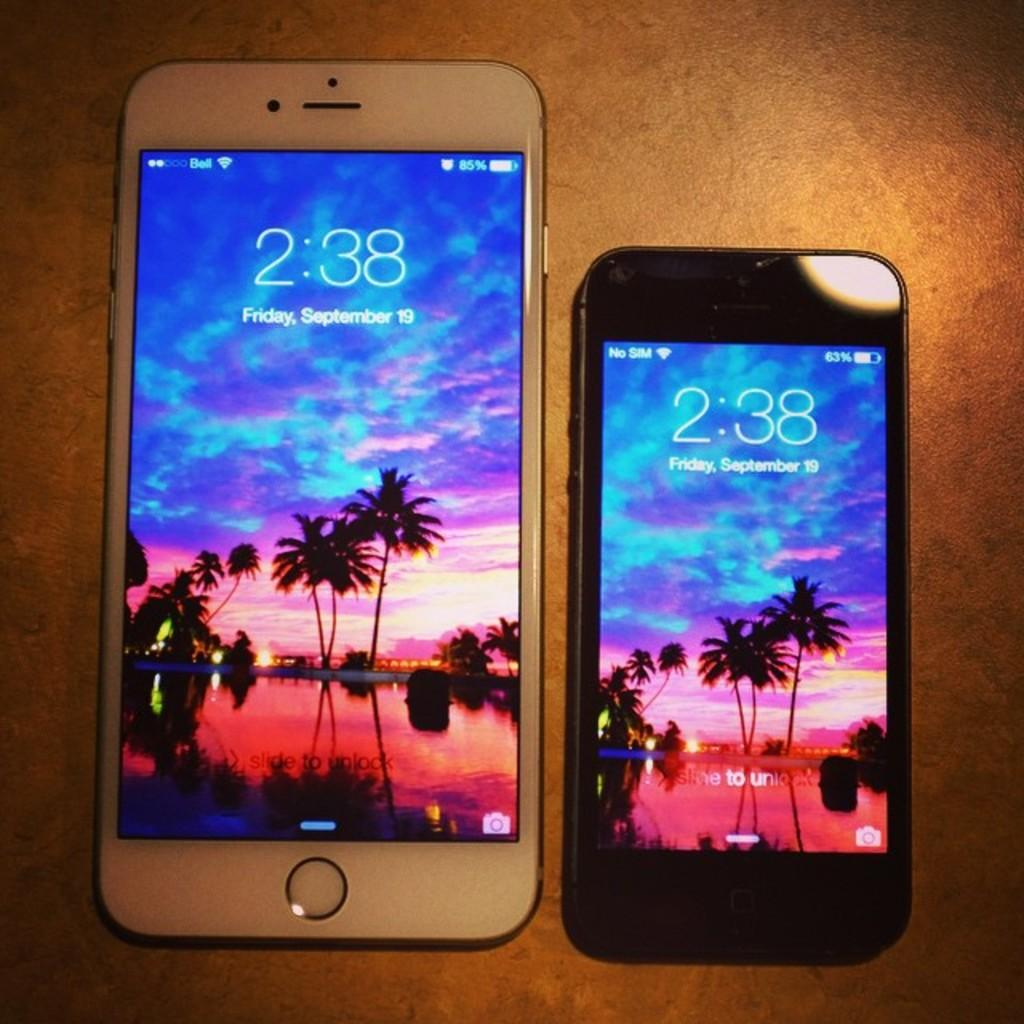<image>
Create a compact narrative representing the image presented. Two iphones displaying Friday, September 19th at 2:38. 